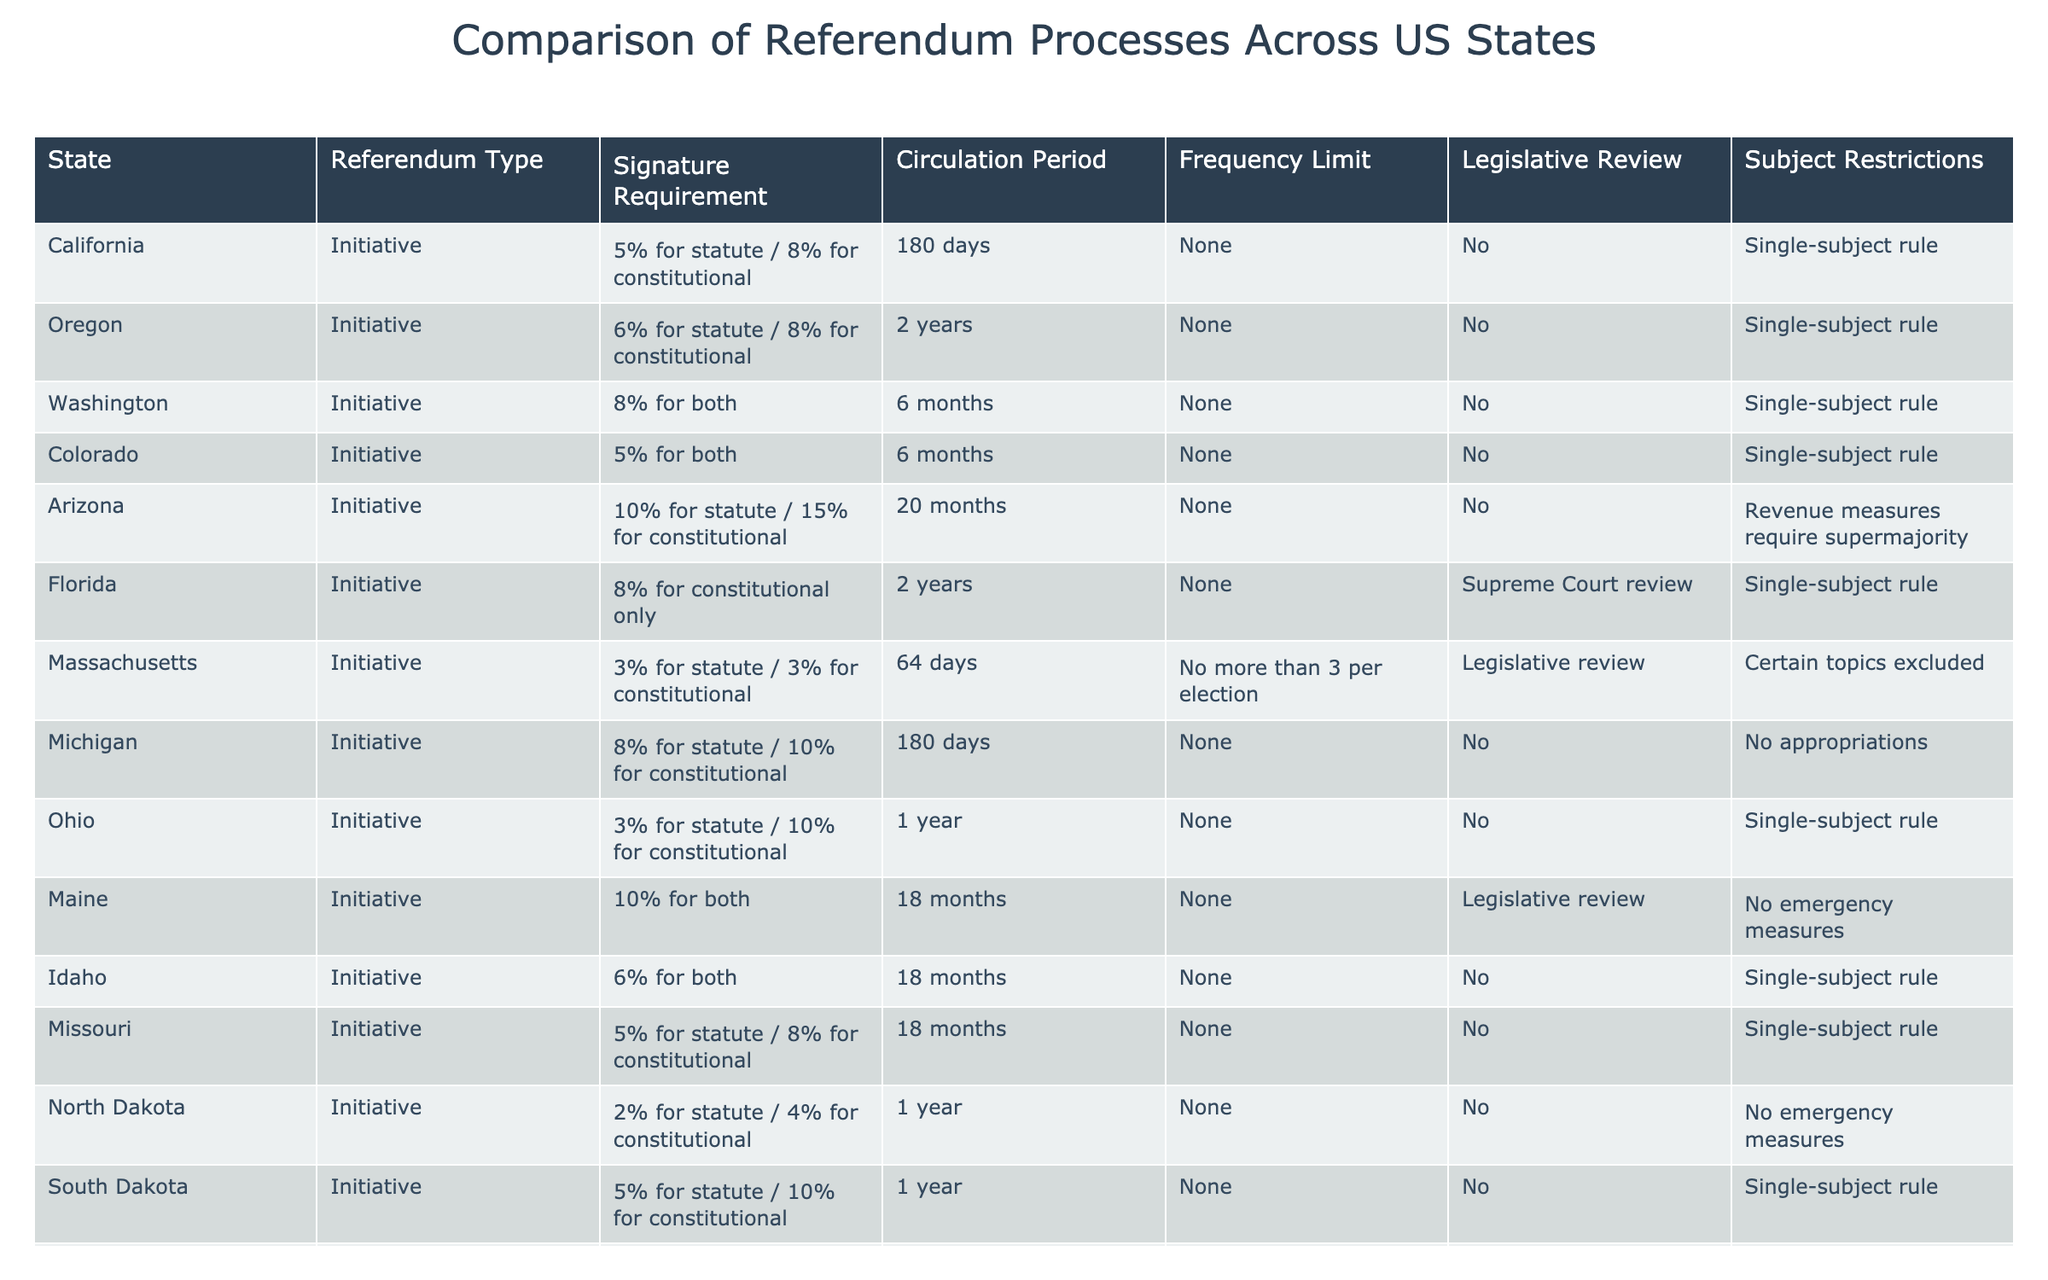What is the signature requirement for an initiative in California? The table lists California's signature requirement for an initiative as 5% for statute and 8% for constitutional.
Answer: 5% for statute / 8% for constitutional Which state has the longest circulation period for initiatives? According to the table, Oregon has the longest circulation period for initiatives at 2 years.
Answer: Oregon How many states require a legislative review for initiatives? From the table, we can see that Florida, Massachusetts, and Maine have a requirement for legislative review, making it a total of 3 states.
Answer: 3 Is there a state that allows more than one initiative per election? The table indicates that Massachusetts has a limit of no more than 3 initiatives per election, therefore it allows a set number of initiatives rather than just one.
Answer: Yes, Massachusetts Which state has the highest signature requirement for constitutional initiatives? The table shows that Arizona has the highest signature requirement for constitutional initiatives at 15%.
Answer: Arizona What is the average percentage required for statute initiatives across all states in the table? To find the average, we sum the signature requirements for statute initiatives and divide by the number of states: (5+6+8+5+10+8+3+10+2+5+5) / 11 = 5.727. Rounding gives us approximately 5.73%.
Answer: Approximately 5.73% Are there any states that have restrictions on subject matter for initiatives? Yes, the table indicates that Florida, Massachusetts, and Arizona have specific subject restrictions on initiatives.
Answer: Yes Which state has a requirement for a supermajority on revenue measures? According to the table, Arizona requires a supermajority for revenue measures.
Answer: Arizona How does the circulation period for initiatives in Washington compare to that in Florida? The table lists the circulation period for initiatives in Washington as 6 months and in Florida as 2 years, meaning Florida has the longer circulation period.
Answer: Florida has a longer circulation period Which states have a single-subject rule for initiatives? The table lists that California, Oregon, Washington, Colorado, Florida, Ohio, Idaho, South Dakota, and Utah have a single-subject rule for initiatives. This totals to 9 states.
Answer: 9 states 